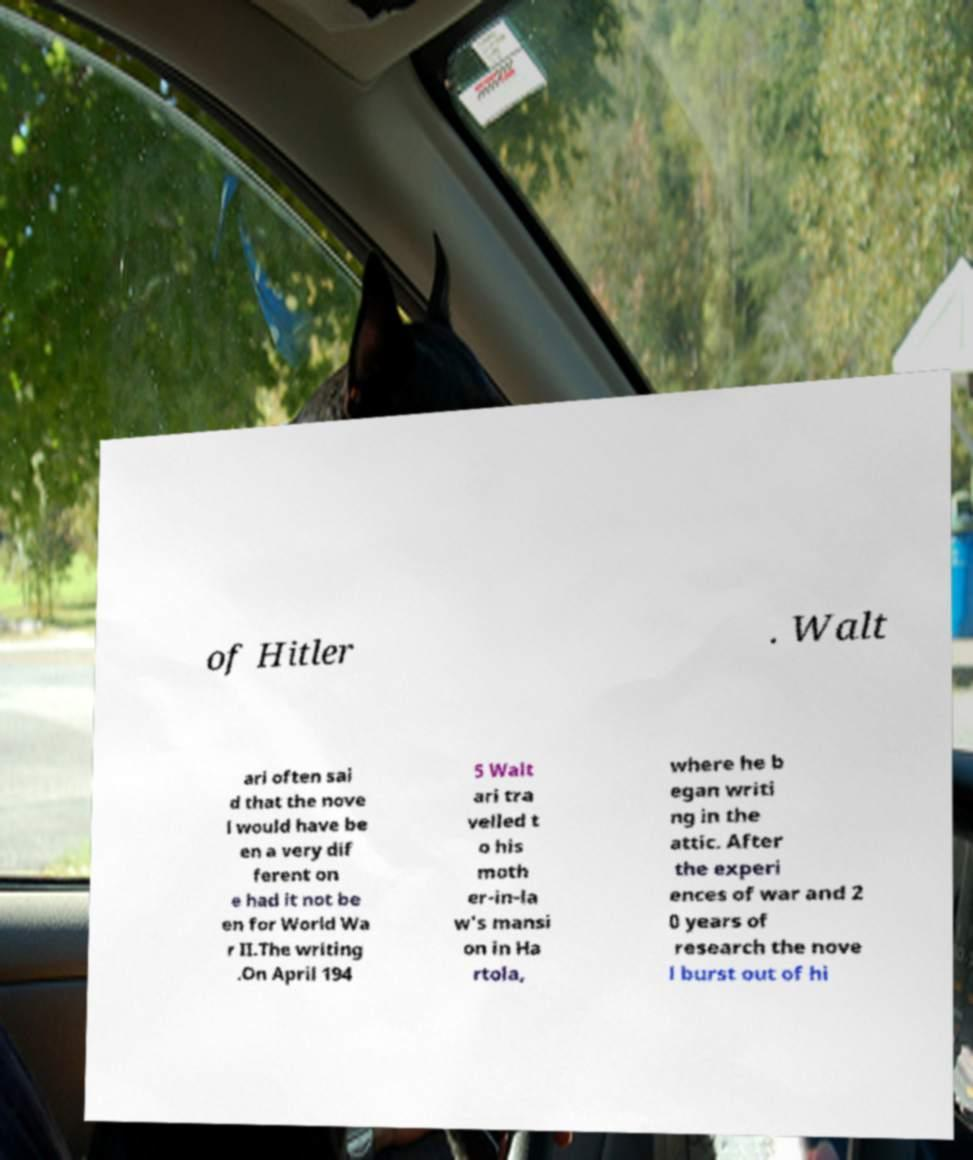Please identify and transcribe the text found in this image. of Hitler . Walt ari often sai d that the nove l would have be en a very dif ferent on e had it not be en for World Wa r II.The writing .On April 194 5 Walt ari tra velled t o his moth er-in-la w's mansi on in Ha rtola, where he b egan writi ng in the attic. After the experi ences of war and 2 0 years of research the nove l burst out of hi 